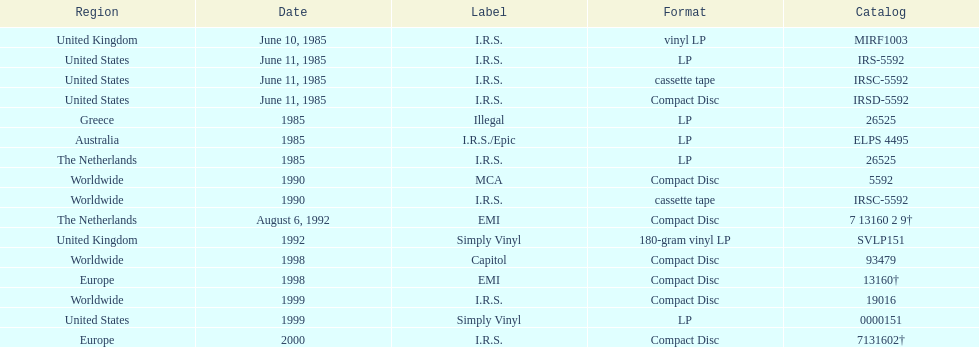Can you provide at least two labels responsible for releasing the group's albums? I.R.S., Illegal. 